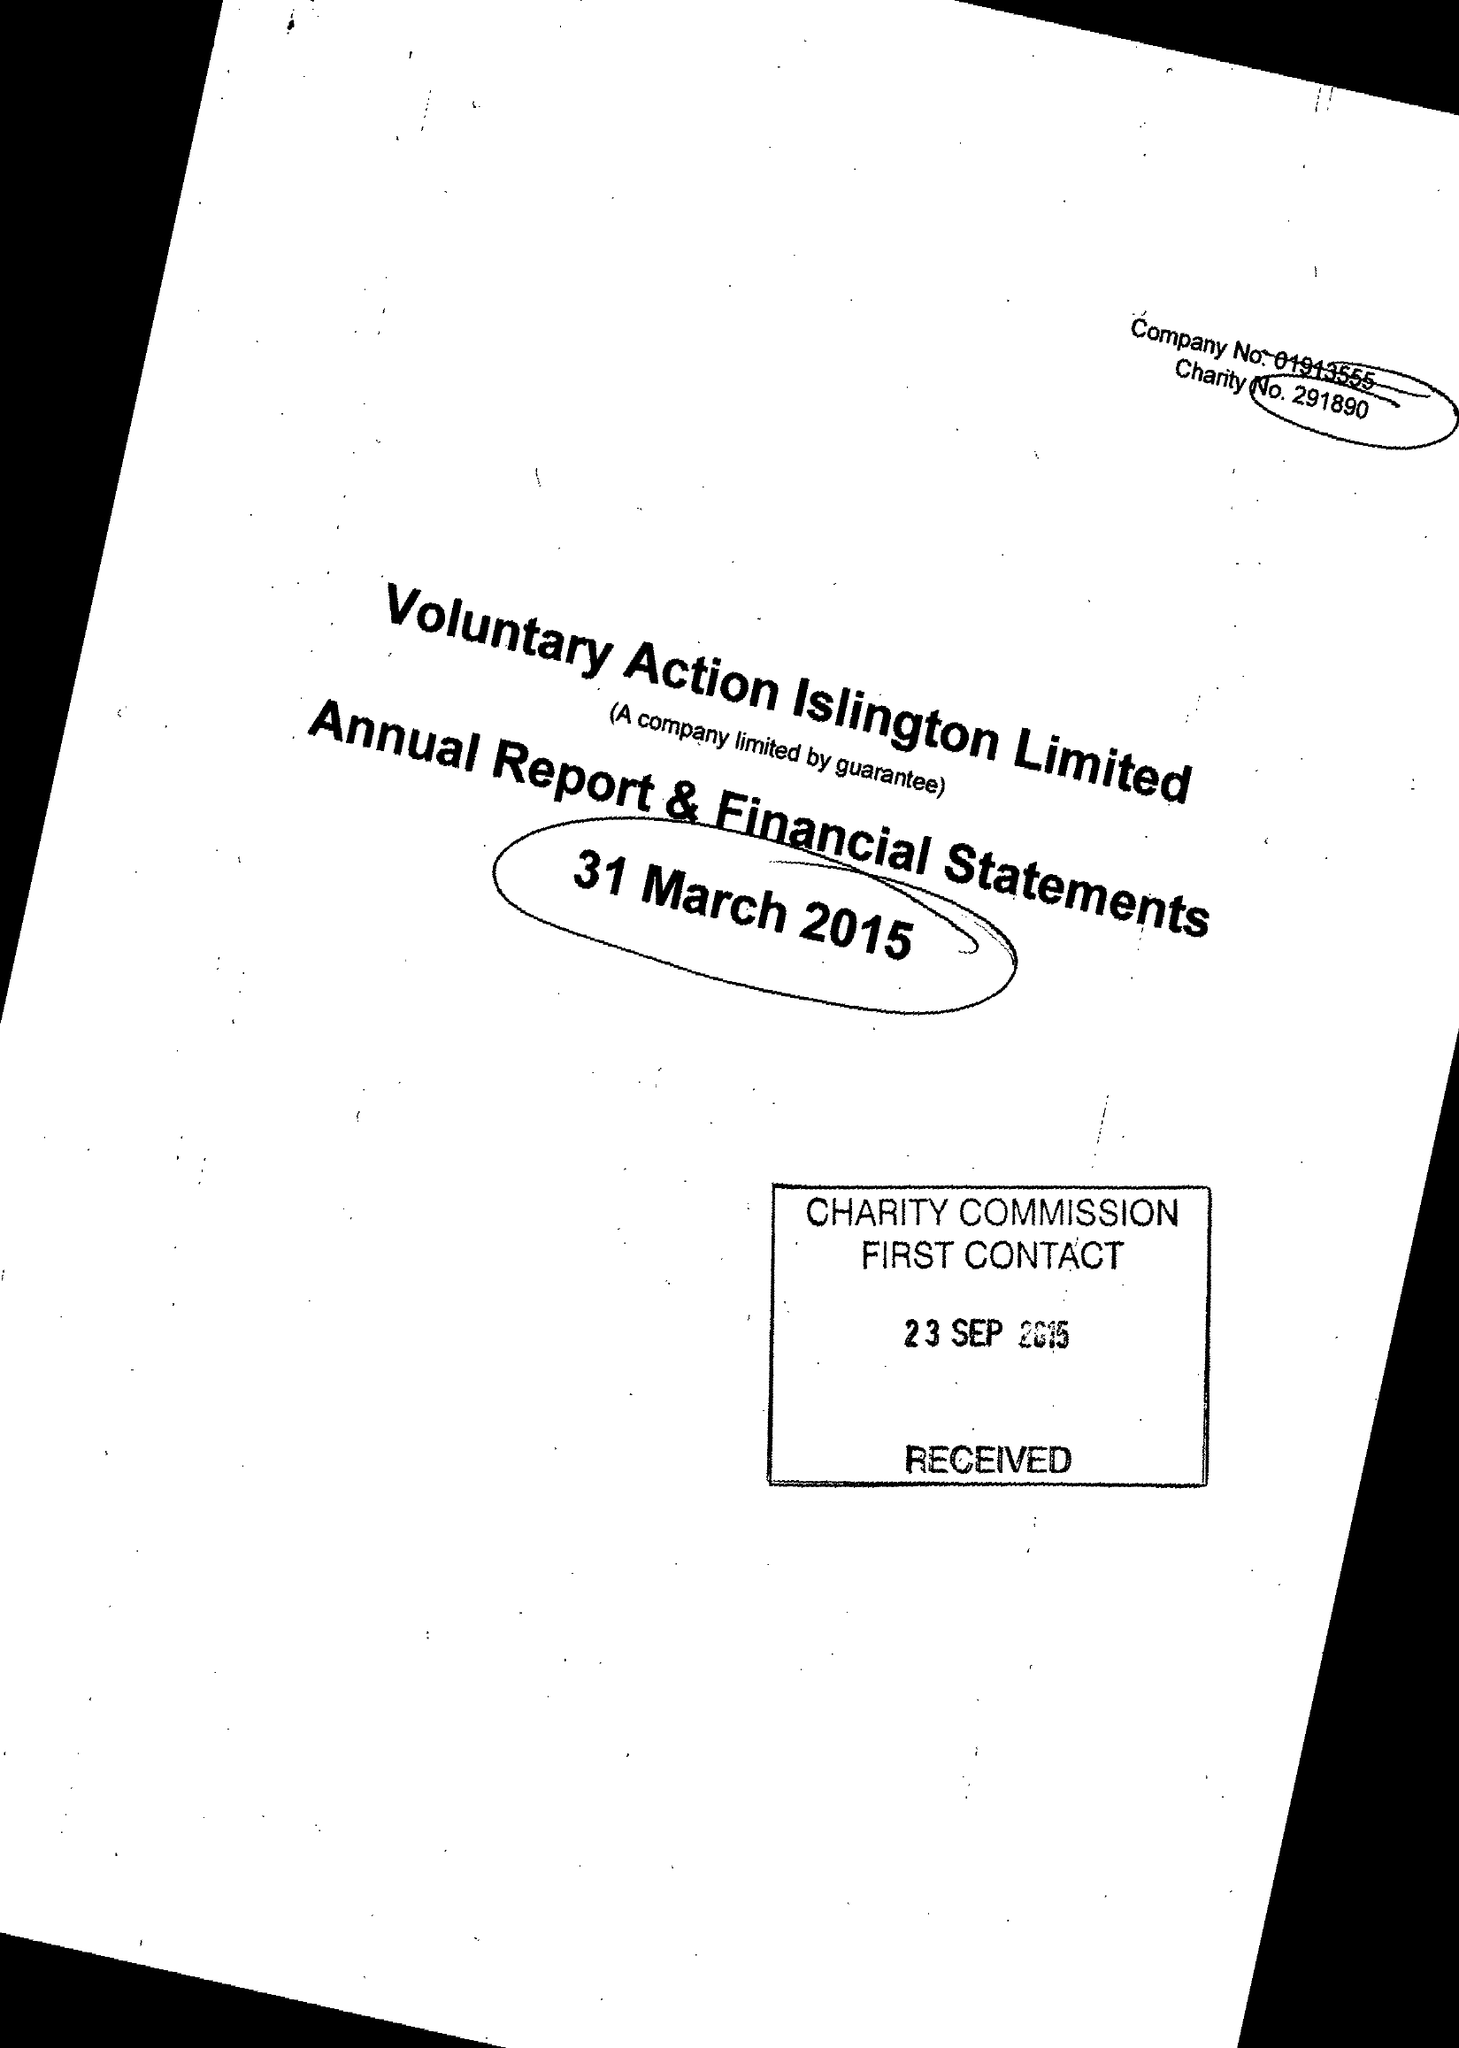What is the value for the spending_annually_in_british_pounds?
Answer the question using a single word or phrase. 561023.00 